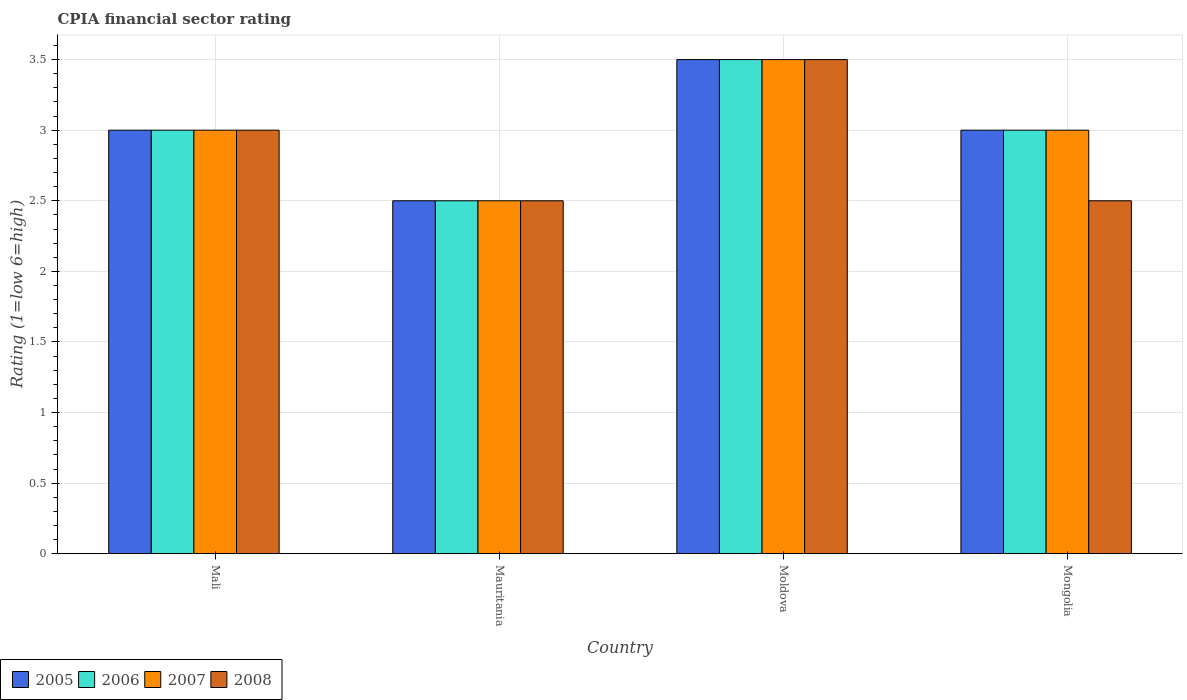How many groups of bars are there?
Your response must be concise. 4. Are the number of bars per tick equal to the number of legend labels?
Provide a succinct answer. Yes. How many bars are there on the 3rd tick from the left?
Offer a very short reply. 4. How many bars are there on the 1st tick from the right?
Keep it short and to the point. 4. What is the label of the 2nd group of bars from the left?
Keep it short and to the point. Mauritania. What is the CPIA rating in 2007 in Mauritania?
Keep it short and to the point. 2.5. Across all countries, what is the minimum CPIA rating in 2007?
Your response must be concise. 2.5. In which country was the CPIA rating in 2008 maximum?
Offer a terse response. Moldova. In which country was the CPIA rating in 2008 minimum?
Provide a short and direct response. Mauritania. What is the average CPIA rating in 2008 per country?
Your answer should be compact. 2.88. Is the CPIA rating in 2007 in Mauritania less than that in Moldova?
Make the answer very short. Yes. Is the difference between the CPIA rating in 2008 in Mali and Mongolia greater than the difference between the CPIA rating in 2006 in Mali and Mongolia?
Make the answer very short. Yes. What is the difference between the highest and the second highest CPIA rating in 2006?
Keep it short and to the point. -0.5. What is the difference between the highest and the lowest CPIA rating in 2007?
Provide a short and direct response. 1. What does the 2nd bar from the left in Mali represents?
Keep it short and to the point. 2006. Is it the case that in every country, the sum of the CPIA rating in 2007 and CPIA rating in 2005 is greater than the CPIA rating in 2008?
Your answer should be compact. Yes. How many bars are there?
Your response must be concise. 16. What is the difference between two consecutive major ticks on the Y-axis?
Your response must be concise. 0.5. Does the graph contain any zero values?
Give a very brief answer. No. Does the graph contain grids?
Keep it short and to the point. Yes. Where does the legend appear in the graph?
Your answer should be compact. Bottom left. How many legend labels are there?
Provide a succinct answer. 4. What is the title of the graph?
Your response must be concise. CPIA financial sector rating. What is the label or title of the X-axis?
Offer a terse response. Country. What is the label or title of the Y-axis?
Keep it short and to the point. Rating (1=low 6=high). What is the Rating (1=low 6=high) in 2006 in Mali?
Keep it short and to the point. 3. What is the Rating (1=low 6=high) of 2007 in Mali?
Provide a succinct answer. 3. What is the Rating (1=low 6=high) in 2005 in Mauritania?
Provide a short and direct response. 2.5. What is the Rating (1=low 6=high) of 2008 in Mauritania?
Make the answer very short. 2.5. What is the Rating (1=low 6=high) in 2005 in Moldova?
Ensure brevity in your answer.  3.5. What is the Rating (1=low 6=high) in 2006 in Moldova?
Make the answer very short. 3.5. What is the Rating (1=low 6=high) in 2005 in Mongolia?
Ensure brevity in your answer.  3. What is the Rating (1=low 6=high) of 2007 in Mongolia?
Your answer should be compact. 3. Across all countries, what is the maximum Rating (1=low 6=high) in 2008?
Provide a succinct answer. 3.5. Across all countries, what is the minimum Rating (1=low 6=high) in 2005?
Make the answer very short. 2.5. Across all countries, what is the minimum Rating (1=low 6=high) of 2007?
Give a very brief answer. 2.5. Across all countries, what is the minimum Rating (1=low 6=high) in 2008?
Offer a terse response. 2.5. What is the total Rating (1=low 6=high) of 2007 in the graph?
Offer a terse response. 12. What is the difference between the Rating (1=low 6=high) of 2005 in Mali and that in Mauritania?
Offer a terse response. 0.5. What is the difference between the Rating (1=low 6=high) in 2006 in Mali and that in Mauritania?
Make the answer very short. 0.5. What is the difference between the Rating (1=low 6=high) in 2008 in Mali and that in Mauritania?
Make the answer very short. 0.5. What is the difference between the Rating (1=low 6=high) in 2006 in Mali and that in Moldova?
Make the answer very short. -0.5. What is the difference between the Rating (1=low 6=high) of 2007 in Mali and that in Moldova?
Offer a terse response. -0.5. What is the difference between the Rating (1=low 6=high) in 2008 in Mali and that in Moldova?
Your answer should be very brief. -0.5. What is the difference between the Rating (1=low 6=high) in 2008 in Mali and that in Mongolia?
Ensure brevity in your answer.  0.5. What is the difference between the Rating (1=low 6=high) in 2005 in Mauritania and that in Moldova?
Provide a succinct answer. -1. What is the difference between the Rating (1=low 6=high) of 2006 in Mauritania and that in Moldova?
Make the answer very short. -1. What is the difference between the Rating (1=low 6=high) in 2007 in Mauritania and that in Moldova?
Provide a short and direct response. -1. What is the difference between the Rating (1=low 6=high) of 2006 in Mauritania and that in Mongolia?
Your answer should be very brief. -0.5. What is the difference between the Rating (1=low 6=high) of 2007 in Mauritania and that in Mongolia?
Your answer should be compact. -0.5. What is the difference between the Rating (1=low 6=high) in 2005 in Moldova and that in Mongolia?
Ensure brevity in your answer.  0.5. What is the difference between the Rating (1=low 6=high) in 2007 in Moldova and that in Mongolia?
Keep it short and to the point. 0.5. What is the difference between the Rating (1=low 6=high) in 2008 in Moldova and that in Mongolia?
Give a very brief answer. 1. What is the difference between the Rating (1=low 6=high) in 2005 in Mali and the Rating (1=low 6=high) in 2007 in Mauritania?
Your response must be concise. 0.5. What is the difference between the Rating (1=low 6=high) of 2006 in Mali and the Rating (1=low 6=high) of 2008 in Mauritania?
Your response must be concise. 0.5. What is the difference between the Rating (1=low 6=high) of 2007 in Mali and the Rating (1=low 6=high) of 2008 in Mauritania?
Your answer should be very brief. 0.5. What is the difference between the Rating (1=low 6=high) of 2005 in Mali and the Rating (1=low 6=high) of 2007 in Moldova?
Keep it short and to the point. -0.5. What is the difference between the Rating (1=low 6=high) of 2005 in Mali and the Rating (1=low 6=high) of 2008 in Moldova?
Provide a short and direct response. -0.5. What is the difference between the Rating (1=low 6=high) of 2006 in Mali and the Rating (1=low 6=high) of 2007 in Moldova?
Your response must be concise. -0.5. What is the difference between the Rating (1=low 6=high) in 2007 in Mali and the Rating (1=low 6=high) in 2008 in Moldova?
Give a very brief answer. -0.5. What is the difference between the Rating (1=low 6=high) in 2005 in Mali and the Rating (1=low 6=high) in 2006 in Mongolia?
Provide a succinct answer. 0. What is the difference between the Rating (1=low 6=high) of 2006 in Mali and the Rating (1=low 6=high) of 2008 in Mongolia?
Provide a succinct answer. 0.5. What is the difference between the Rating (1=low 6=high) in 2005 in Mauritania and the Rating (1=low 6=high) in 2007 in Moldova?
Offer a terse response. -1. What is the difference between the Rating (1=low 6=high) of 2005 in Mauritania and the Rating (1=low 6=high) of 2008 in Moldova?
Provide a short and direct response. -1. What is the difference between the Rating (1=low 6=high) in 2007 in Mauritania and the Rating (1=low 6=high) in 2008 in Moldova?
Your answer should be compact. -1. What is the difference between the Rating (1=low 6=high) in 2005 in Mauritania and the Rating (1=low 6=high) in 2006 in Mongolia?
Your answer should be compact. -0.5. What is the difference between the Rating (1=low 6=high) in 2006 in Mauritania and the Rating (1=low 6=high) in 2007 in Mongolia?
Provide a succinct answer. -0.5. What is the difference between the Rating (1=low 6=high) of 2006 in Mauritania and the Rating (1=low 6=high) of 2008 in Mongolia?
Give a very brief answer. 0. What is the difference between the Rating (1=low 6=high) in 2005 in Moldova and the Rating (1=low 6=high) in 2006 in Mongolia?
Give a very brief answer. 0.5. What is the difference between the Rating (1=low 6=high) in 2005 in Moldova and the Rating (1=low 6=high) in 2008 in Mongolia?
Provide a short and direct response. 1. What is the difference between the Rating (1=low 6=high) of 2006 in Moldova and the Rating (1=low 6=high) of 2008 in Mongolia?
Give a very brief answer. 1. What is the average Rating (1=low 6=high) in 2005 per country?
Provide a succinct answer. 3. What is the average Rating (1=low 6=high) of 2008 per country?
Your answer should be very brief. 2.88. What is the difference between the Rating (1=low 6=high) of 2005 and Rating (1=low 6=high) of 2007 in Mali?
Make the answer very short. 0. What is the difference between the Rating (1=low 6=high) of 2007 and Rating (1=low 6=high) of 2008 in Mali?
Offer a very short reply. 0. What is the difference between the Rating (1=low 6=high) of 2005 and Rating (1=low 6=high) of 2006 in Moldova?
Ensure brevity in your answer.  0. What is the difference between the Rating (1=low 6=high) in 2005 and Rating (1=low 6=high) in 2007 in Moldova?
Provide a short and direct response. 0. What is the difference between the Rating (1=low 6=high) of 2006 and Rating (1=low 6=high) of 2008 in Moldova?
Offer a very short reply. 0. What is the difference between the Rating (1=low 6=high) of 2007 and Rating (1=low 6=high) of 2008 in Moldova?
Your answer should be compact. 0. What is the difference between the Rating (1=low 6=high) of 2005 and Rating (1=low 6=high) of 2008 in Mongolia?
Offer a terse response. 0.5. What is the difference between the Rating (1=low 6=high) in 2007 and Rating (1=low 6=high) in 2008 in Mongolia?
Provide a short and direct response. 0.5. What is the ratio of the Rating (1=low 6=high) of 2006 in Mali to that in Mauritania?
Your answer should be compact. 1.2. What is the ratio of the Rating (1=low 6=high) in 2008 in Mali to that in Mauritania?
Keep it short and to the point. 1.2. What is the ratio of the Rating (1=low 6=high) of 2007 in Mali to that in Moldova?
Offer a terse response. 0.86. What is the ratio of the Rating (1=low 6=high) in 2006 in Mali to that in Mongolia?
Offer a terse response. 1. What is the ratio of the Rating (1=low 6=high) in 2005 in Mauritania to that in Moldova?
Your response must be concise. 0.71. What is the ratio of the Rating (1=low 6=high) of 2006 in Mauritania to that in Moldova?
Ensure brevity in your answer.  0.71. What is the ratio of the Rating (1=low 6=high) of 2007 in Mauritania to that in Moldova?
Offer a terse response. 0.71. What is the ratio of the Rating (1=low 6=high) in 2007 in Mauritania to that in Mongolia?
Your answer should be very brief. 0.83. What is the difference between the highest and the second highest Rating (1=low 6=high) of 2005?
Give a very brief answer. 0.5. What is the difference between the highest and the second highest Rating (1=low 6=high) of 2007?
Your response must be concise. 0.5. What is the difference between the highest and the second highest Rating (1=low 6=high) in 2008?
Give a very brief answer. 0.5. What is the difference between the highest and the lowest Rating (1=low 6=high) in 2005?
Your response must be concise. 1. What is the difference between the highest and the lowest Rating (1=low 6=high) in 2007?
Make the answer very short. 1. What is the difference between the highest and the lowest Rating (1=low 6=high) in 2008?
Your response must be concise. 1. 